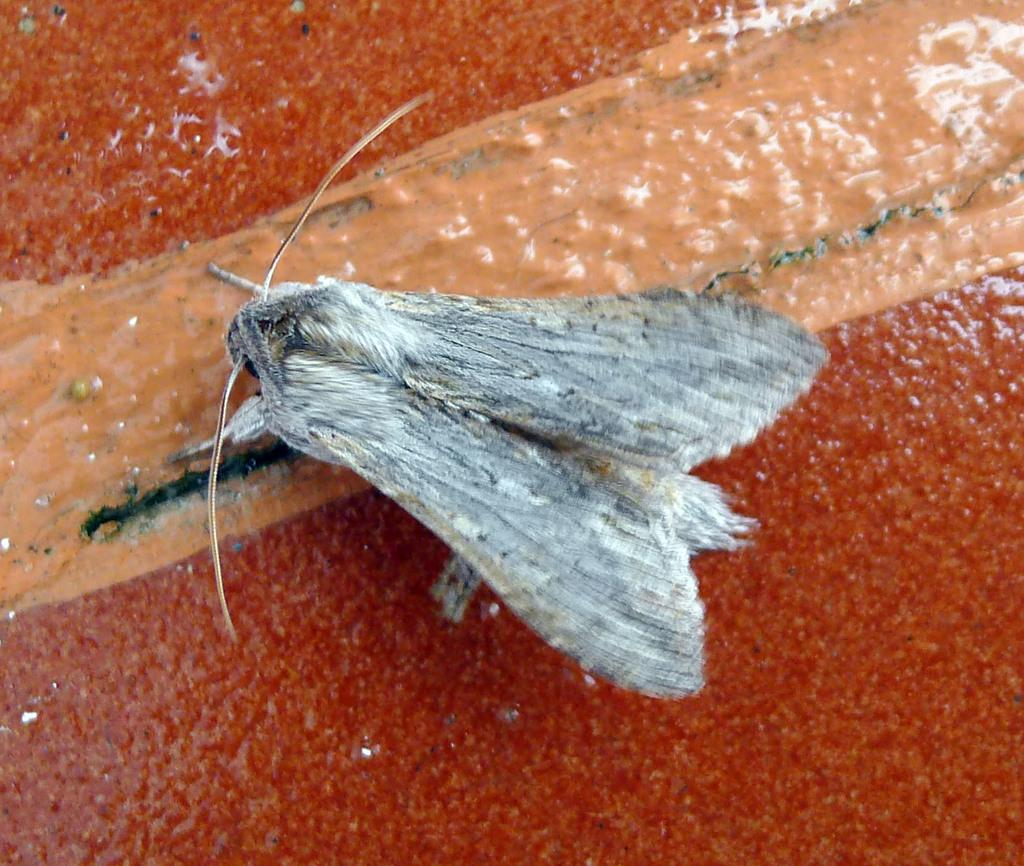What type of creature is present in the image? There is an insect in the image. What color is the insect? The insect is red in color. How many people are attending the surprise feast in the image? There is no mention of a feast or people in the image; it only features an insect. 